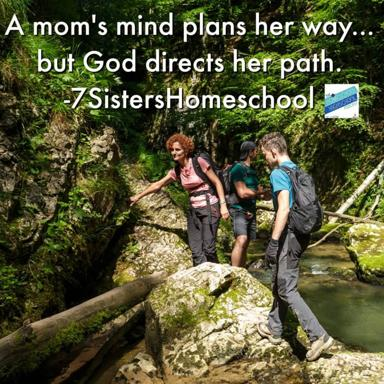What does the presence of a fallen log over the stream suggest about this forest? The presence of a fallen log across the stream suggests this is a mature, minimally disturbed forest ecosystem. Logs like this not only serve as natural bridges but also play a crucial role in the environment as habitats for various species and as part of the nutrient cycling process in a forest's ecology. 